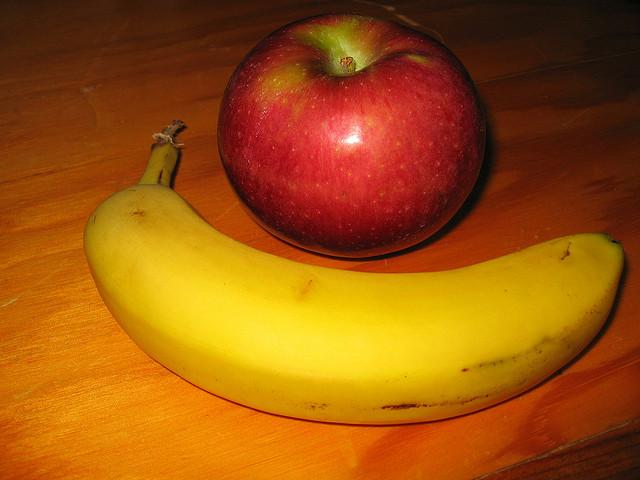Is the fruit in a bowl?
Be succinct. No. How many bananas are there?
Give a very brief answer. 1. What colors are present in the apple?
Quick response, please. Red and green. Who put these fruits on the table?
Be succinct. Photographer. Is this a smiley face?
Give a very brief answer. No. What color is the apple?
Answer briefly. Red. Is the fruit hanging?
Give a very brief answer. No. 